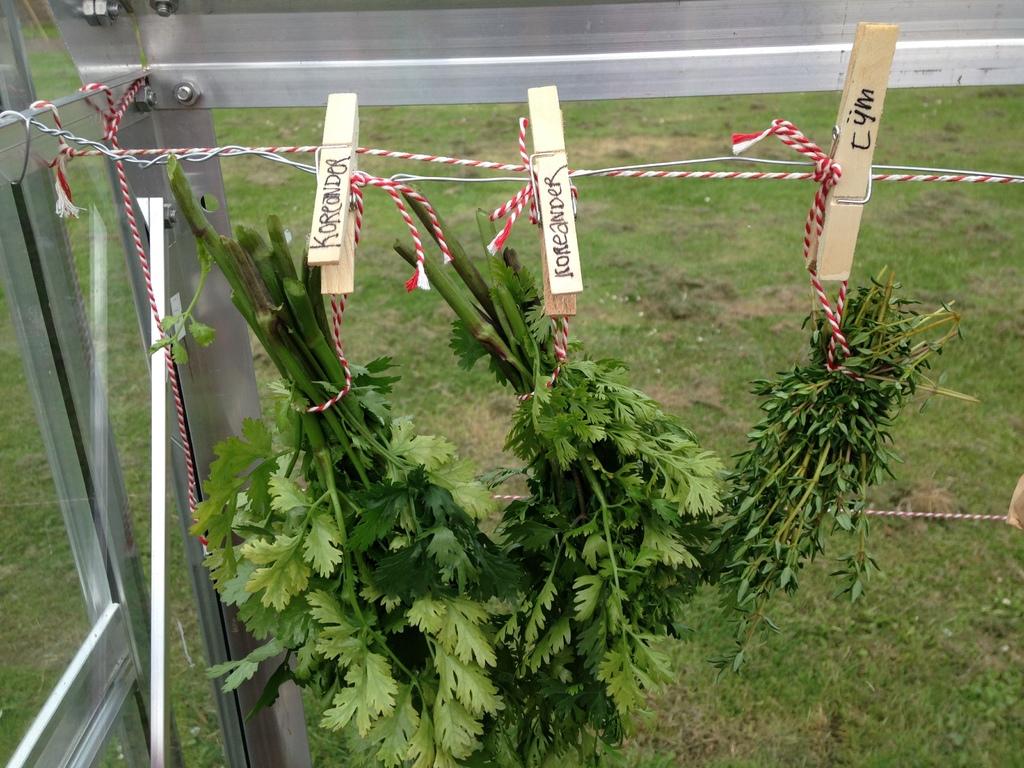What type of greens are those?
Give a very brief answer. Koreander, tym. 